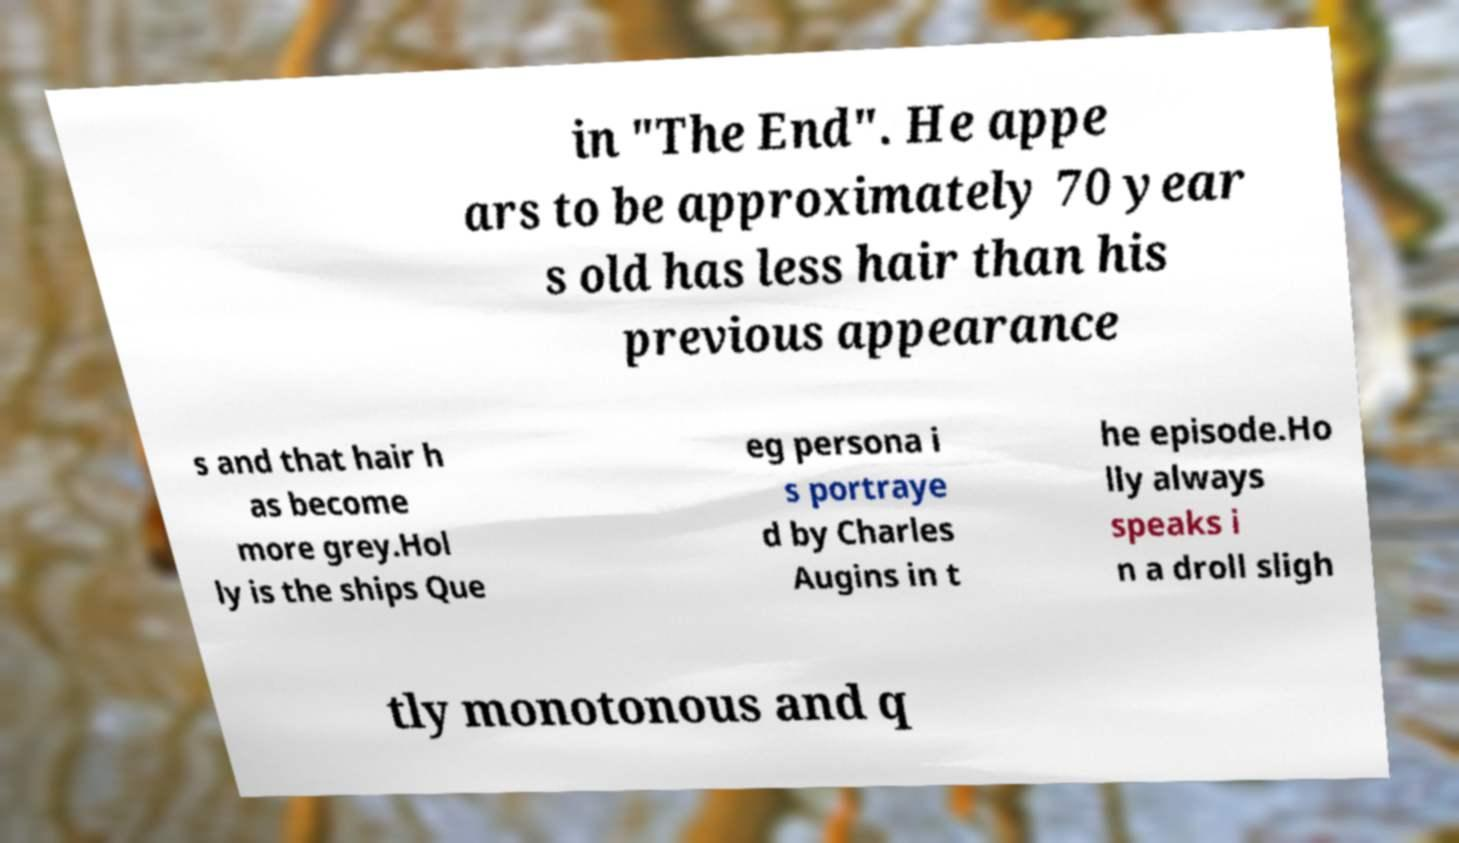Please identify and transcribe the text found in this image. in "The End". He appe ars to be approximately 70 year s old has less hair than his previous appearance s and that hair h as become more grey.Hol ly is the ships Que eg persona i s portraye d by Charles Augins in t he episode.Ho lly always speaks i n a droll sligh tly monotonous and q 